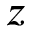Convert formula to latex. <formula><loc_0><loc_0><loc_500><loc_500>z</formula> 